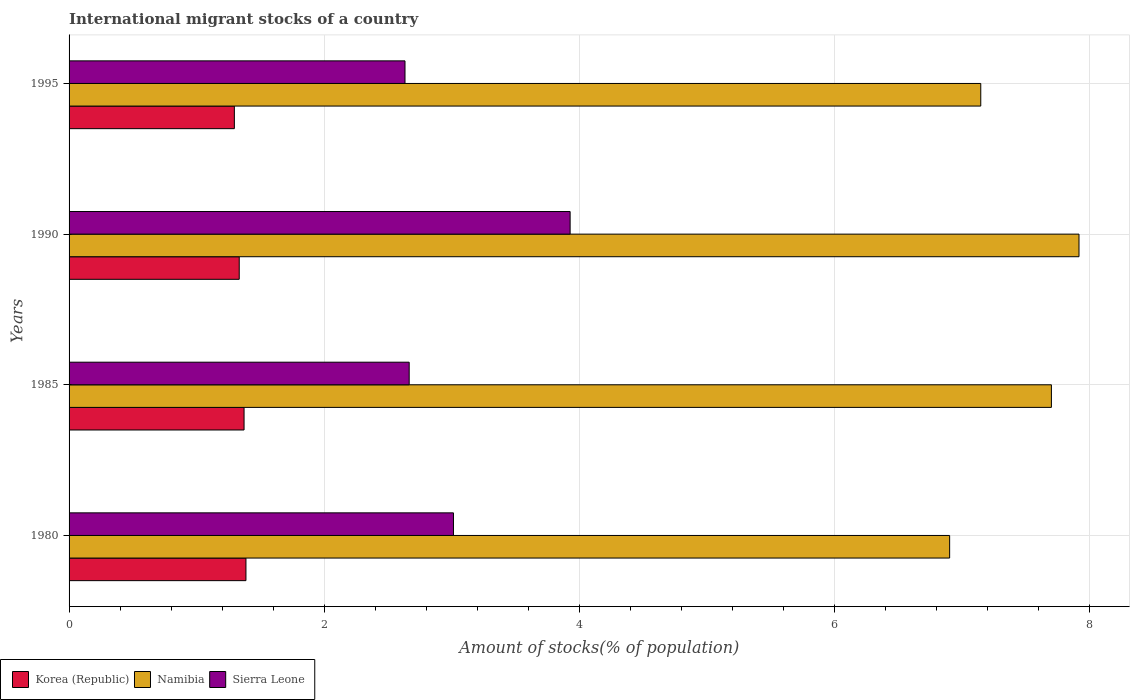How many different coloured bars are there?
Your response must be concise. 3. How many groups of bars are there?
Offer a very short reply. 4. How many bars are there on the 4th tick from the bottom?
Your answer should be very brief. 3. In how many cases, is the number of bars for a given year not equal to the number of legend labels?
Provide a succinct answer. 0. What is the amount of stocks in in Namibia in 1995?
Your answer should be very brief. 7.15. Across all years, what is the maximum amount of stocks in in Korea (Republic)?
Provide a succinct answer. 1.39. Across all years, what is the minimum amount of stocks in in Korea (Republic)?
Offer a very short reply. 1.3. In which year was the amount of stocks in in Sierra Leone maximum?
Ensure brevity in your answer.  1990. What is the total amount of stocks in in Korea (Republic) in the graph?
Your answer should be very brief. 5.39. What is the difference between the amount of stocks in in Sierra Leone in 1980 and that in 1990?
Give a very brief answer. -0.91. What is the difference between the amount of stocks in in Namibia in 1990 and the amount of stocks in in Sierra Leone in 1985?
Make the answer very short. 5.25. What is the average amount of stocks in in Korea (Republic) per year?
Keep it short and to the point. 1.35. In the year 1995, what is the difference between the amount of stocks in in Namibia and amount of stocks in in Korea (Republic)?
Ensure brevity in your answer.  5.85. In how many years, is the amount of stocks in in Namibia greater than 3.6 %?
Make the answer very short. 4. What is the ratio of the amount of stocks in in Korea (Republic) in 1985 to that in 1990?
Provide a short and direct response. 1.03. Is the amount of stocks in in Namibia in 1985 less than that in 1990?
Your answer should be compact. Yes. Is the difference between the amount of stocks in in Namibia in 1985 and 1995 greater than the difference between the amount of stocks in in Korea (Republic) in 1985 and 1995?
Offer a terse response. Yes. What is the difference between the highest and the second highest amount of stocks in in Korea (Republic)?
Offer a terse response. 0.01. What is the difference between the highest and the lowest amount of stocks in in Sierra Leone?
Give a very brief answer. 1.29. In how many years, is the amount of stocks in in Namibia greater than the average amount of stocks in in Namibia taken over all years?
Provide a short and direct response. 2. Is the sum of the amount of stocks in in Sierra Leone in 1985 and 1995 greater than the maximum amount of stocks in in Namibia across all years?
Ensure brevity in your answer.  No. What does the 1st bar from the bottom in 1980 represents?
Your answer should be very brief. Korea (Republic). Is it the case that in every year, the sum of the amount of stocks in in Namibia and amount of stocks in in Sierra Leone is greater than the amount of stocks in in Korea (Republic)?
Make the answer very short. Yes. How many bars are there?
Keep it short and to the point. 12. Are all the bars in the graph horizontal?
Provide a succinct answer. Yes. How many years are there in the graph?
Your answer should be very brief. 4. Where does the legend appear in the graph?
Give a very brief answer. Bottom left. What is the title of the graph?
Offer a very short reply. International migrant stocks of a country. Does "Netherlands" appear as one of the legend labels in the graph?
Your answer should be compact. No. What is the label or title of the X-axis?
Offer a terse response. Amount of stocks(% of population). What is the Amount of stocks(% of population) of Korea (Republic) in 1980?
Provide a short and direct response. 1.39. What is the Amount of stocks(% of population) of Namibia in 1980?
Offer a very short reply. 6.91. What is the Amount of stocks(% of population) of Sierra Leone in 1980?
Your response must be concise. 3.01. What is the Amount of stocks(% of population) of Korea (Republic) in 1985?
Keep it short and to the point. 1.37. What is the Amount of stocks(% of population) of Namibia in 1985?
Make the answer very short. 7.7. What is the Amount of stocks(% of population) in Sierra Leone in 1985?
Your answer should be very brief. 2.67. What is the Amount of stocks(% of population) of Korea (Republic) in 1990?
Your response must be concise. 1.33. What is the Amount of stocks(% of population) of Namibia in 1990?
Your answer should be very brief. 7.92. What is the Amount of stocks(% of population) in Sierra Leone in 1990?
Give a very brief answer. 3.93. What is the Amount of stocks(% of population) in Korea (Republic) in 1995?
Give a very brief answer. 1.3. What is the Amount of stocks(% of population) of Namibia in 1995?
Make the answer very short. 7.15. What is the Amount of stocks(% of population) of Sierra Leone in 1995?
Your response must be concise. 2.63. Across all years, what is the maximum Amount of stocks(% of population) of Korea (Republic)?
Give a very brief answer. 1.39. Across all years, what is the maximum Amount of stocks(% of population) in Namibia?
Offer a very short reply. 7.92. Across all years, what is the maximum Amount of stocks(% of population) of Sierra Leone?
Offer a terse response. 3.93. Across all years, what is the minimum Amount of stocks(% of population) of Korea (Republic)?
Your answer should be very brief. 1.3. Across all years, what is the minimum Amount of stocks(% of population) of Namibia?
Provide a short and direct response. 6.91. Across all years, what is the minimum Amount of stocks(% of population) in Sierra Leone?
Your response must be concise. 2.63. What is the total Amount of stocks(% of population) of Korea (Republic) in the graph?
Ensure brevity in your answer.  5.39. What is the total Amount of stocks(% of population) in Namibia in the graph?
Your answer should be compact. 29.68. What is the total Amount of stocks(% of population) in Sierra Leone in the graph?
Your answer should be compact. 12.24. What is the difference between the Amount of stocks(% of population) of Korea (Republic) in 1980 and that in 1985?
Ensure brevity in your answer.  0.01. What is the difference between the Amount of stocks(% of population) in Namibia in 1980 and that in 1985?
Your answer should be compact. -0.8. What is the difference between the Amount of stocks(% of population) in Sierra Leone in 1980 and that in 1985?
Your answer should be compact. 0.35. What is the difference between the Amount of stocks(% of population) of Korea (Republic) in 1980 and that in 1990?
Provide a succinct answer. 0.05. What is the difference between the Amount of stocks(% of population) of Namibia in 1980 and that in 1990?
Keep it short and to the point. -1.01. What is the difference between the Amount of stocks(% of population) of Sierra Leone in 1980 and that in 1990?
Your answer should be compact. -0.91. What is the difference between the Amount of stocks(% of population) of Korea (Republic) in 1980 and that in 1995?
Offer a very short reply. 0.09. What is the difference between the Amount of stocks(% of population) in Namibia in 1980 and that in 1995?
Keep it short and to the point. -0.24. What is the difference between the Amount of stocks(% of population) in Sierra Leone in 1980 and that in 1995?
Your answer should be compact. 0.38. What is the difference between the Amount of stocks(% of population) of Korea (Republic) in 1985 and that in 1990?
Offer a very short reply. 0.04. What is the difference between the Amount of stocks(% of population) of Namibia in 1985 and that in 1990?
Provide a short and direct response. -0.22. What is the difference between the Amount of stocks(% of population) in Sierra Leone in 1985 and that in 1990?
Your answer should be very brief. -1.26. What is the difference between the Amount of stocks(% of population) of Korea (Republic) in 1985 and that in 1995?
Keep it short and to the point. 0.08. What is the difference between the Amount of stocks(% of population) of Namibia in 1985 and that in 1995?
Your answer should be compact. 0.55. What is the difference between the Amount of stocks(% of population) in Sierra Leone in 1985 and that in 1995?
Your answer should be very brief. 0.03. What is the difference between the Amount of stocks(% of population) in Korea (Republic) in 1990 and that in 1995?
Ensure brevity in your answer.  0.04. What is the difference between the Amount of stocks(% of population) of Namibia in 1990 and that in 1995?
Offer a terse response. 0.77. What is the difference between the Amount of stocks(% of population) of Sierra Leone in 1990 and that in 1995?
Provide a succinct answer. 1.29. What is the difference between the Amount of stocks(% of population) of Korea (Republic) in 1980 and the Amount of stocks(% of population) of Namibia in 1985?
Ensure brevity in your answer.  -6.32. What is the difference between the Amount of stocks(% of population) in Korea (Republic) in 1980 and the Amount of stocks(% of population) in Sierra Leone in 1985?
Ensure brevity in your answer.  -1.28. What is the difference between the Amount of stocks(% of population) of Namibia in 1980 and the Amount of stocks(% of population) of Sierra Leone in 1985?
Provide a succinct answer. 4.24. What is the difference between the Amount of stocks(% of population) in Korea (Republic) in 1980 and the Amount of stocks(% of population) in Namibia in 1990?
Offer a very short reply. -6.53. What is the difference between the Amount of stocks(% of population) of Korea (Republic) in 1980 and the Amount of stocks(% of population) of Sierra Leone in 1990?
Offer a very short reply. -2.54. What is the difference between the Amount of stocks(% of population) in Namibia in 1980 and the Amount of stocks(% of population) in Sierra Leone in 1990?
Provide a short and direct response. 2.98. What is the difference between the Amount of stocks(% of population) in Korea (Republic) in 1980 and the Amount of stocks(% of population) in Namibia in 1995?
Make the answer very short. -5.76. What is the difference between the Amount of stocks(% of population) in Korea (Republic) in 1980 and the Amount of stocks(% of population) in Sierra Leone in 1995?
Your answer should be very brief. -1.25. What is the difference between the Amount of stocks(% of population) in Namibia in 1980 and the Amount of stocks(% of population) in Sierra Leone in 1995?
Your answer should be very brief. 4.27. What is the difference between the Amount of stocks(% of population) in Korea (Republic) in 1985 and the Amount of stocks(% of population) in Namibia in 1990?
Offer a terse response. -6.55. What is the difference between the Amount of stocks(% of population) of Korea (Republic) in 1985 and the Amount of stocks(% of population) of Sierra Leone in 1990?
Ensure brevity in your answer.  -2.56. What is the difference between the Amount of stocks(% of population) in Namibia in 1985 and the Amount of stocks(% of population) in Sierra Leone in 1990?
Your answer should be compact. 3.77. What is the difference between the Amount of stocks(% of population) in Korea (Republic) in 1985 and the Amount of stocks(% of population) in Namibia in 1995?
Your response must be concise. -5.78. What is the difference between the Amount of stocks(% of population) of Korea (Republic) in 1985 and the Amount of stocks(% of population) of Sierra Leone in 1995?
Keep it short and to the point. -1.26. What is the difference between the Amount of stocks(% of population) of Namibia in 1985 and the Amount of stocks(% of population) of Sierra Leone in 1995?
Offer a terse response. 5.07. What is the difference between the Amount of stocks(% of population) in Korea (Republic) in 1990 and the Amount of stocks(% of population) in Namibia in 1995?
Offer a very short reply. -5.81. What is the difference between the Amount of stocks(% of population) of Korea (Republic) in 1990 and the Amount of stocks(% of population) of Sierra Leone in 1995?
Ensure brevity in your answer.  -1.3. What is the difference between the Amount of stocks(% of population) in Namibia in 1990 and the Amount of stocks(% of population) in Sierra Leone in 1995?
Ensure brevity in your answer.  5.29. What is the average Amount of stocks(% of population) in Korea (Republic) per year?
Make the answer very short. 1.35. What is the average Amount of stocks(% of population) of Namibia per year?
Provide a succinct answer. 7.42. What is the average Amount of stocks(% of population) of Sierra Leone per year?
Give a very brief answer. 3.06. In the year 1980, what is the difference between the Amount of stocks(% of population) of Korea (Republic) and Amount of stocks(% of population) of Namibia?
Provide a succinct answer. -5.52. In the year 1980, what is the difference between the Amount of stocks(% of population) of Korea (Republic) and Amount of stocks(% of population) of Sierra Leone?
Your answer should be very brief. -1.63. In the year 1980, what is the difference between the Amount of stocks(% of population) of Namibia and Amount of stocks(% of population) of Sierra Leone?
Offer a very short reply. 3.89. In the year 1985, what is the difference between the Amount of stocks(% of population) in Korea (Republic) and Amount of stocks(% of population) in Namibia?
Make the answer very short. -6.33. In the year 1985, what is the difference between the Amount of stocks(% of population) in Korea (Republic) and Amount of stocks(% of population) in Sierra Leone?
Give a very brief answer. -1.29. In the year 1985, what is the difference between the Amount of stocks(% of population) of Namibia and Amount of stocks(% of population) of Sierra Leone?
Make the answer very short. 5.04. In the year 1990, what is the difference between the Amount of stocks(% of population) of Korea (Republic) and Amount of stocks(% of population) of Namibia?
Offer a very short reply. -6.59. In the year 1990, what is the difference between the Amount of stocks(% of population) in Korea (Republic) and Amount of stocks(% of population) in Sierra Leone?
Ensure brevity in your answer.  -2.59. In the year 1990, what is the difference between the Amount of stocks(% of population) of Namibia and Amount of stocks(% of population) of Sierra Leone?
Make the answer very short. 3.99. In the year 1995, what is the difference between the Amount of stocks(% of population) in Korea (Republic) and Amount of stocks(% of population) in Namibia?
Provide a short and direct response. -5.85. In the year 1995, what is the difference between the Amount of stocks(% of population) of Korea (Republic) and Amount of stocks(% of population) of Sierra Leone?
Provide a short and direct response. -1.34. In the year 1995, what is the difference between the Amount of stocks(% of population) of Namibia and Amount of stocks(% of population) of Sierra Leone?
Offer a terse response. 4.51. What is the ratio of the Amount of stocks(% of population) in Korea (Republic) in 1980 to that in 1985?
Your answer should be compact. 1.01. What is the ratio of the Amount of stocks(% of population) in Namibia in 1980 to that in 1985?
Your answer should be very brief. 0.9. What is the ratio of the Amount of stocks(% of population) of Sierra Leone in 1980 to that in 1985?
Make the answer very short. 1.13. What is the ratio of the Amount of stocks(% of population) of Korea (Republic) in 1980 to that in 1990?
Offer a terse response. 1.04. What is the ratio of the Amount of stocks(% of population) in Namibia in 1980 to that in 1990?
Make the answer very short. 0.87. What is the ratio of the Amount of stocks(% of population) in Sierra Leone in 1980 to that in 1990?
Your answer should be very brief. 0.77. What is the ratio of the Amount of stocks(% of population) in Korea (Republic) in 1980 to that in 1995?
Provide a short and direct response. 1.07. What is the ratio of the Amount of stocks(% of population) of Namibia in 1980 to that in 1995?
Make the answer very short. 0.97. What is the ratio of the Amount of stocks(% of population) in Sierra Leone in 1980 to that in 1995?
Your answer should be very brief. 1.14. What is the ratio of the Amount of stocks(% of population) of Korea (Republic) in 1985 to that in 1990?
Make the answer very short. 1.03. What is the ratio of the Amount of stocks(% of population) in Namibia in 1985 to that in 1990?
Give a very brief answer. 0.97. What is the ratio of the Amount of stocks(% of population) of Sierra Leone in 1985 to that in 1990?
Ensure brevity in your answer.  0.68. What is the ratio of the Amount of stocks(% of population) of Korea (Republic) in 1985 to that in 1995?
Provide a short and direct response. 1.06. What is the ratio of the Amount of stocks(% of population) of Namibia in 1985 to that in 1995?
Your answer should be very brief. 1.08. What is the ratio of the Amount of stocks(% of population) in Sierra Leone in 1985 to that in 1995?
Give a very brief answer. 1.01. What is the ratio of the Amount of stocks(% of population) in Korea (Republic) in 1990 to that in 1995?
Your response must be concise. 1.03. What is the ratio of the Amount of stocks(% of population) of Namibia in 1990 to that in 1995?
Keep it short and to the point. 1.11. What is the ratio of the Amount of stocks(% of population) in Sierra Leone in 1990 to that in 1995?
Your response must be concise. 1.49. What is the difference between the highest and the second highest Amount of stocks(% of population) of Korea (Republic)?
Offer a very short reply. 0.01. What is the difference between the highest and the second highest Amount of stocks(% of population) in Namibia?
Give a very brief answer. 0.22. What is the difference between the highest and the second highest Amount of stocks(% of population) in Sierra Leone?
Give a very brief answer. 0.91. What is the difference between the highest and the lowest Amount of stocks(% of population) in Korea (Republic)?
Give a very brief answer. 0.09. What is the difference between the highest and the lowest Amount of stocks(% of population) of Namibia?
Make the answer very short. 1.01. What is the difference between the highest and the lowest Amount of stocks(% of population) of Sierra Leone?
Offer a terse response. 1.29. 